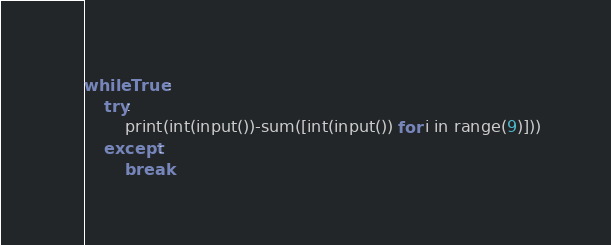Convert code to text. <code><loc_0><loc_0><loc_500><loc_500><_Python_>while True:
    try:
        print(int(input())-sum([int(input()) for i in range(9)]))
    except:
        break
</code> 